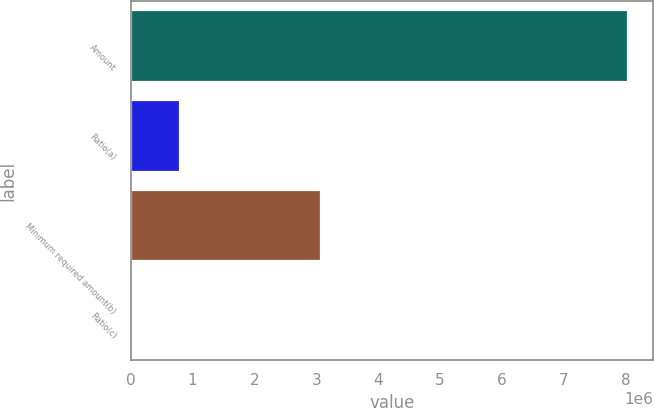Convert chart to OTSL. <chart><loc_0><loc_0><loc_500><loc_500><bar_chart><fcel>Amount<fcel>Ratio(a)<fcel>Minimum required amount(b)<fcel>Ratio(c)<nl><fcel>8.04318e+06<fcel>804326<fcel>3.0771e+06<fcel>8.56<nl></chart> 